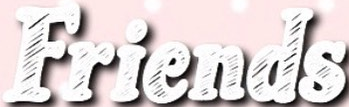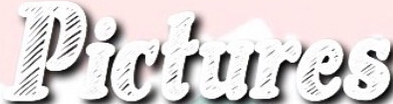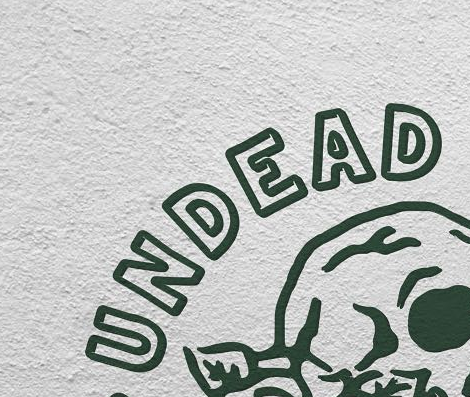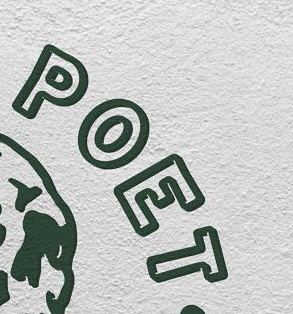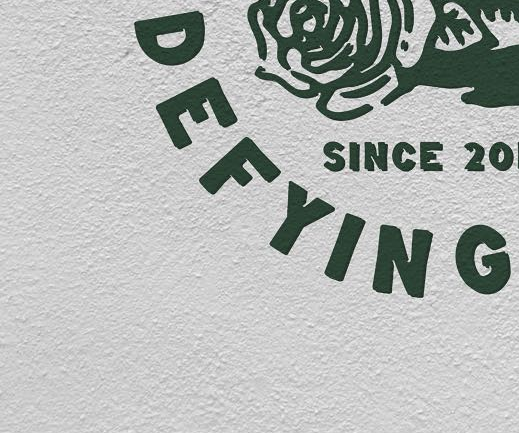Read the text content from these images in order, separated by a semicolon. Friends; Pictures; UNDEAD; POET; DEFYING 